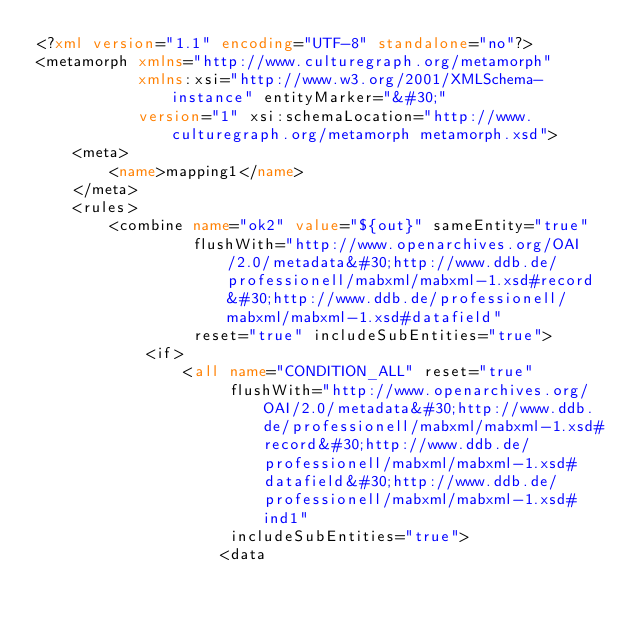Convert code to text. <code><loc_0><loc_0><loc_500><loc_500><_XML_><?xml version="1.1" encoding="UTF-8" standalone="no"?>
<metamorph xmlns="http://www.culturegraph.org/metamorph"
		   xmlns:xsi="http://www.w3.org/2001/XMLSchema-instance" entityMarker="&#30;"
		   version="1" xsi:schemaLocation="http://www.culturegraph.org/metamorph metamorph.xsd">
	<meta>
		<name>mapping1</name>
	</meta>
	<rules>
		<combine name="ok2" value="${out}" sameEntity="true"
				 flushWith="http://www.openarchives.org/OAI/2.0/metadata&#30;http://www.ddb.de/professionell/mabxml/mabxml-1.xsd#record&#30;http://www.ddb.de/professionell/mabxml/mabxml-1.xsd#datafield"
				 reset="true" includeSubEntities="true">
			<if>
				<all name="CONDITION_ALL" reset="true"
					 flushWith="http://www.openarchives.org/OAI/2.0/metadata&#30;http://www.ddb.de/professionell/mabxml/mabxml-1.xsd#record&#30;http://www.ddb.de/professionell/mabxml/mabxml-1.xsd#datafield&#30;http://www.ddb.de/professionell/mabxml/mabxml-1.xsd#ind1"
					 includeSubEntities="true">
					<data</code> 